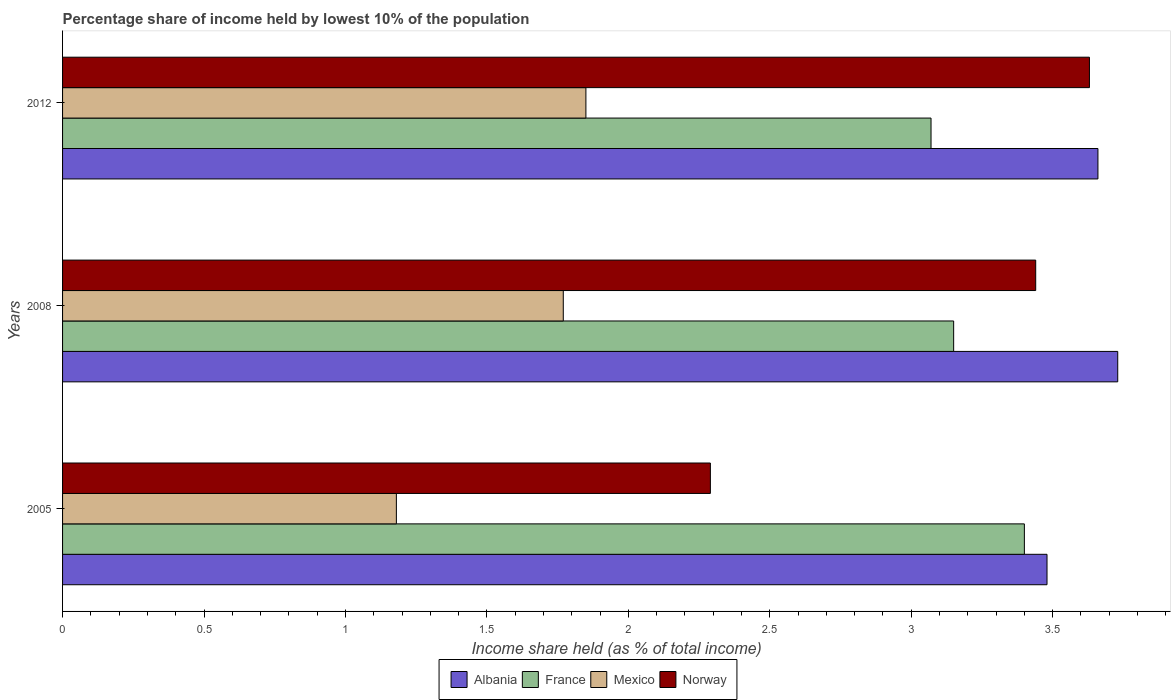How many different coloured bars are there?
Give a very brief answer. 4. How many groups of bars are there?
Your answer should be compact. 3. Are the number of bars per tick equal to the number of legend labels?
Offer a terse response. Yes. How many bars are there on the 3rd tick from the top?
Give a very brief answer. 4. In how many cases, is the number of bars for a given year not equal to the number of legend labels?
Offer a terse response. 0. What is the percentage share of income held by lowest 10% of the population in Norway in 2005?
Ensure brevity in your answer.  2.29. Across all years, what is the maximum percentage share of income held by lowest 10% of the population in Mexico?
Offer a very short reply. 1.85. Across all years, what is the minimum percentage share of income held by lowest 10% of the population in France?
Offer a terse response. 3.07. In which year was the percentage share of income held by lowest 10% of the population in France minimum?
Provide a short and direct response. 2012. What is the total percentage share of income held by lowest 10% of the population in Mexico in the graph?
Give a very brief answer. 4.8. What is the difference between the percentage share of income held by lowest 10% of the population in Mexico in 2005 and that in 2008?
Your answer should be very brief. -0.59. What is the difference between the percentage share of income held by lowest 10% of the population in France in 2005 and the percentage share of income held by lowest 10% of the population in Norway in 2012?
Ensure brevity in your answer.  -0.23. What is the average percentage share of income held by lowest 10% of the population in France per year?
Keep it short and to the point. 3.21. In the year 2008, what is the difference between the percentage share of income held by lowest 10% of the population in Mexico and percentage share of income held by lowest 10% of the population in Albania?
Keep it short and to the point. -1.96. What is the ratio of the percentage share of income held by lowest 10% of the population in Mexico in 2005 to that in 2008?
Give a very brief answer. 0.67. Is the percentage share of income held by lowest 10% of the population in Norway in 2008 less than that in 2012?
Keep it short and to the point. Yes. What is the difference between the highest and the second highest percentage share of income held by lowest 10% of the population in Mexico?
Make the answer very short. 0.08. What is the difference between the highest and the lowest percentage share of income held by lowest 10% of the population in Mexico?
Provide a succinct answer. 0.67. Is it the case that in every year, the sum of the percentage share of income held by lowest 10% of the population in Mexico and percentage share of income held by lowest 10% of the population in France is greater than the sum of percentage share of income held by lowest 10% of the population in Albania and percentage share of income held by lowest 10% of the population in Norway?
Offer a terse response. No. What does the 2nd bar from the top in 2012 represents?
Your response must be concise. Mexico. What does the 3rd bar from the bottom in 2012 represents?
Keep it short and to the point. Mexico. How many bars are there?
Provide a short and direct response. 12. How many years are there in the graph?
Ensure brevity in your answer.  3. Does the graph contain any zero values?
Offer a terse response. No. Does the graph contain grids?
Provide a short and direct response. No. How many legend labels are there?
Provide a succinct answer. 4. What is the title of the graph?
Ensure brevity in your answer.  Percentage share of income held by lowest 10% of the population. Does "Switzerland" appear as one of the legend labels in the graph?
Offer a very short reply. No. What is the label or title of the X-axis?
Offer a terse response. Income share held (as % of total income). What is the Income share held (as % of total income) in Albania in 2005?
Make the answer very short. 3.48. What is the Income share held (as % of total income) in France in 2005?
Offer a terse response. 3.4. What is the Income share held (as % of total income) of Mexico in 2005?
Provide a succinct answer. 1.18. What is the Income share held (as % of total income) in Norway in 2005?
Your answer should be compact. 2.29. What is the Income share held (as % of total income) of Albania in 2008?
Your answer should be compact. 3.73. What is the Income share held (as % of total income) of France in 2008?
Make the answer very short. 3.15. What is the Income share held (as % of total income) of Mexico in 2008?
Keep it short and to the point. 1.77. What is the Income share held (as % of total income) in Norway in 2008?
Keep it short and to the point. 3.44. What is the Income share held (as % of total income) in Albania in 2012?
Ensure brevity in your answer.  3.66. What is the Income share held (as % of total income) in France in 2012?
Offer a very short reply. 3.07. What is the Income share held (as % of total income) in Mexico in 2012?
Give a very brief answer. 1.85. What is the Income share held (as % of total income) in Norway in 2012?
Offer a very short reply. 3.63. Across all years, what is the maximum Income share held (as % of total income) in Albania?
Your answer should be compact. 3.73. Across all years, what is the maximum Income share held (as % of total income) in Mexico?
Offer a terse response. 1.85. Across all years, what is the maximum Income share held (as % of total income) of Norway?
Your answer should be compact. 3.63. Across all years, what is the minimum Income share held (as % of total income) of Albania?
Provide a succinct answer. 3.48. Across all years, what is the minimum Income share held (as % of total income) in France?
Make the answer very short. 3.07. Across all years, what is the minimum Income share held (as % of total income) in Mexico?
Make the answer very short. 1.18. Across all years, what is the minimum Income share held (as % of total income) of Norway?
Make the answer very short. 2.29. What is the total Income share held (as % of total income) of Albania in the graph?
Offer a terse response. 10.87. What is the total Income share held (as % of total income) of France in the graph?
Offer a terse response. 9.62. What is the total Income share held (as % of total income) of Norway in the graph?
Provide a succinct answer. 9.36. What is the difference between the Income share held (as % of total income) in France in 2005 and that in 2008?
Provide a short and direct response. 0.25. What is the difference between the Income share held (as % of total income) in Mexico in 2005 and that in 2008?
Offer a very short reply. -0.59. What is the difference between the Income share held (as % of total income) in Norway in 2005 and that in 2008?
Provide a succinct answer. -1.15. What is the difference between the Income share held (as % of total income) in Albania in 2005 and that in 2012?
Your answer should be compact. -0.18. What is the difference between the Income share held (as % of total income) of France in 2005 and that in 2012?
Give a very brief answer. 0.33. What is the difference between the Income share held (as % of total income) of Mexico in 2005 and that in 2012?
Keep it short and to the point. -0.67. What is the difference between the Income share held (as % of total income) in Norway in 2005 and that in 2012?
Keep it short and to the point. -1.34. What is the difference between the Income share held (as % of total income) in Albania in 2008 and that in 2012?
Ensure brevity in your answer.  0.07. What is the difference between the Income share held (as % of total income) in Mexico in 2008 and that in 2012?
Your response must be concise. -0.08. What is the difference between the Income share held (as % of total income) in Norway in 2008 and that in 2012?
Offer a very short reply. -0.19. What is the difference between the Income share held (as % of total income) in Albania in 2005 and the Income share held (as % of total income) in France in 2008?
Ensure brevity in your answer.  0.33. What is the difference between the Income share held (as % of total income) of Albania in 2005 and the Income share held (as % of total income) of Mexico in 2008?
Your answer should be compact. 1.71. What is the difference between the Income share held (as % of total income) in Albania in 2005 and the Income share held (as % of total income) in Norway in 2008?
Your answer should be compact. 0.04. What is the difference between the Income share held (as % of total income) of France in 2005 and the Income share held (as % of total income) of Mexico in 2008?
Make the answer very short. 1.63. What is the difference between the Income share held (as % of total income) in France in 2005 and the Income share held (as % of total income) in Norway in 2008?
Provide a short and direct response. -0.04. What is the difference between the Income share held (as % of total income) of Mexico in 2005 and the Income share held (as % of total income) of Norway in 2008?
Ensure brevity in your answer.  -2.26. What is the difference between the Income share held (as % of total income) of Albania in 2005 and the Income share held (as % of total income) of France in 2012?
Your answer should be compact. 0.41. What is the difference between the Income share held (as % of total income) in Albania in 2005 and the Income share held (as % of total income) in Mexico in 2012?
Offer a terse response. 1.63. What is the difference between the Income share held (as % of total income) in Albania in 2005 and the Income share held (as % of total income) in Norway in 2012?
Your answer should be very brief. -0.15. What is the difference between the Income share held (as % of total income) in France in 2005 and the Income share held (as % of total income) in Mexico in 2012?
Offer a very short reply. 1.55. What is the difference between the Income share held (as % of total income) of France in 2005 and the Income share held (as % of total income) of Norway in 2012?
Your answer should be compact. -0.23. What is the difference between the Income share held (as % of total income) of Mexico in 2005 and the Income share held (as % of total income) of Norway in 2012?
Keep it short and to the point. -2.45. What is the difference between the Income share held (as % of total income) of Albania in 2008 and the Income share held (as % of total income) of France in 2012?
Offer a terse response. 0.66. What is the difference between the Income share held (as % of total income) in Albania in 2008 and the Income share held (as % of total income) in Mexico in 2012?
Provide a succinct answer. 1.88. What is the difference between the Income share held (as % of total income) of Albania in 2008 and the Income share held (as % of total income) of Norway in 2012?
Your response must be concise. 0.1. What is the difference between the Income share held (as % of total income) of France in 2008 and the Income share held (as % of total income) of Mexico in 2012?
Provide a succinct answer. 1.3. What is the difference between the Income share held (as % of total income) of France in 2008 and the Income share held (as % of total income) of Norway in 2012?
Ensure brevity in your answer.  -0.48. What is the difference between the Income share held (as % of total income) of Mexico in 2008 and the Income share held (as % of total income) of Norway in 2012?
Make the answer very short. -1.86. What is the average Income share held (as % of total income) in Albania per year?
Offer a very short reply. 3.62. What is the average Income share held (as % of total income) of France per year?
Offer a terse response. 3.21. What is the average Income share held (as % of total income) of Mexico per year?
Your answer should be compact. 1.6. What is the average Income share held (as % of total income) in Norway per year?
Make the answer very short. 3.12. In the year 2005, what is the difference between the Income share held (as % of total income) of Albania and Income share held (as % of total income) of France?
Offer a terse response. 0.08. In the year 2005, what is the difference between the Income share held (as % of total income) of Albania and Income share held (as % of total income) of Norway?
Give a very brief answer. 1.19. In the year 2005, what is the difference between the Income share held (as % of total income) of France and Income share held (as % of total income) of Mexico?
Offer a very short reply. 2.22. In the year 2005, what is the difference between the Income share held (as % of total income) in France and Income share held (as % of total income) in Norway?
Ensure brevity in your answer.  1.11. In the year 2005, what is the difference between the Income share held (as % of total income) in Mexico and Income share held (as % of total income) in Norway?
Provide a short and direct response. -1.11. In the year 2008, what is the difference between the Income share held (as % of total income) of Albania and Income share held (as % of total income) of France?
Provide a succinct answer. 0.58. In the year 2008, what is the difference between the Income share held (as % of total income) of Albania and Income share held (as % of total income) of Mexico?
Make the answer very short. 1.96. In the year 2008, what is the difference between the Income share held (as % of total income) of Albania and Income share held (as % of total income) of Norway?
Your answer should be compact. 0.29. In the year 2008, what is the difference between the Income share held (as % of total income) of France and Income share held (as % of total income) of Mexico?
Your answer should be compact. 1.38. In the year 2008, what is the difference between the Income share held (as % of total income) of France and Income share held (as % of total income) of Norway?
Offer a terse response. -0.29. In the year 2008, what is the difference between the Income share held (as % of total income) of Mexico and Income share held (as % of total income) of Norway?
Your response must be concise. -1.67. In the year 2012, what is the difference between the Income share held (as % of total income) of Albania and Income share held (as % of total income) of France?
Make the answer very short. 0.59. In the year 2012, what is the difference between the Income share held (as % of total income) in Albania and Income share held (as % of total income) in Mexico?
Your answer should be compact. 1.81. In the year 2012, what is the difference between the Income share held (as % of total income) of Albania and Income share held (as % of total income) of Norway?
Provide a succinct answer. 0.03. In the year 2012, what is the difference between the Income share held (as % of total income) in France and Income share held (as % of total income) in Mexico?
Ensure brevity in your answer.  1.22. In the year 2012, what is the difference between the Income share held (as % of total income) in France and Income share held (as % of total income) in Norway?
Offer a very short reply. -0.56. In the year 2012, what is the difference between the Income share held (as % of total income) of Mexico and Income share held (as % of total income) of Norway?
Ensure brevity in your answer.  -1.78. What is the ratio of the Income share held (as % of total income) in Albania in 2005 to that in 2008?
Ensure brevity in your answer.  0.93. What is the ratio of the Income share held (as % of total income) of France in 2005 to that in 2008?
Offer a terse response. 1.08. What is the ratio of the Income share held (as % of total income) of Mexico in 2005 to that in 2008?
Your response must be concise. 0.67. What is the ratio of the Income share held (as % of total income) of Norway in 2005 to that in 2008?
Provide a succinct answer. 0.67. What is the ratio of the Income share held (as % of total income) in Albania in 2005 to that in 2012?
Provide a short and direct response. 0.95. What is the ratio of the Income share held (as % of total income) in France in 2005 to that in 2012?
Provide a short and direct response. 1.11. What is the ratio of the Income share held (as % of total income) of Mexico in 2005 to that in 2012?
Provide a succinct answer. 0.64. What is the ratio of the Income share held (as % of total income) of Norway in 2005 to that in 2012?
Your answer should be very brief. 0.63. What is the ratio of the Income share held (as % of total income) of Albania in 2008 to that in 2012?
Your answer should be compact. 1.02. What is the ratio of the Income share held (as % of total income) of France in 2008 to that in 2012?
Provide a succinct answer. 1.03. What is the ratio of the Income share held (as % of total income) of Mexico in 2008 to that in 2012?
Your answer should be very brief. 0.96. What is the ratio of the Income share held (as % of total income) in Norway in 2008 to that in 2012?
Your answer should be very brief. 0.95. What is the difference between the highest and the second highest Income share held (as % of total income) of Albania?
Your answer should be very brief. 0.07. What is the difference between the highest and the second highest Income share held (as % of total income) of France?
Ensure brevity in your answer.  0.25. What is the difference between the highest and the second highest Income share held (as % of total income) in Norway?
Offer a terse response. 0.19. What is the difference between the highest and the lowest Income share held (as % of total income) of Albania?
Provide a short and direct response. 0.25. What is the difference between the highest and the lowest Income share held (as % of total income) in France?
Provide a succinct answer. 0.33. What is the difference between the highest and the lowest Income share held (as % of total income) in Mexico?
Your answer should be very brief. 0.67. What is the difference between the highest and the lowest Income share held (as % of total income) in Norway?
Keep it short and to the point. 1.34. 